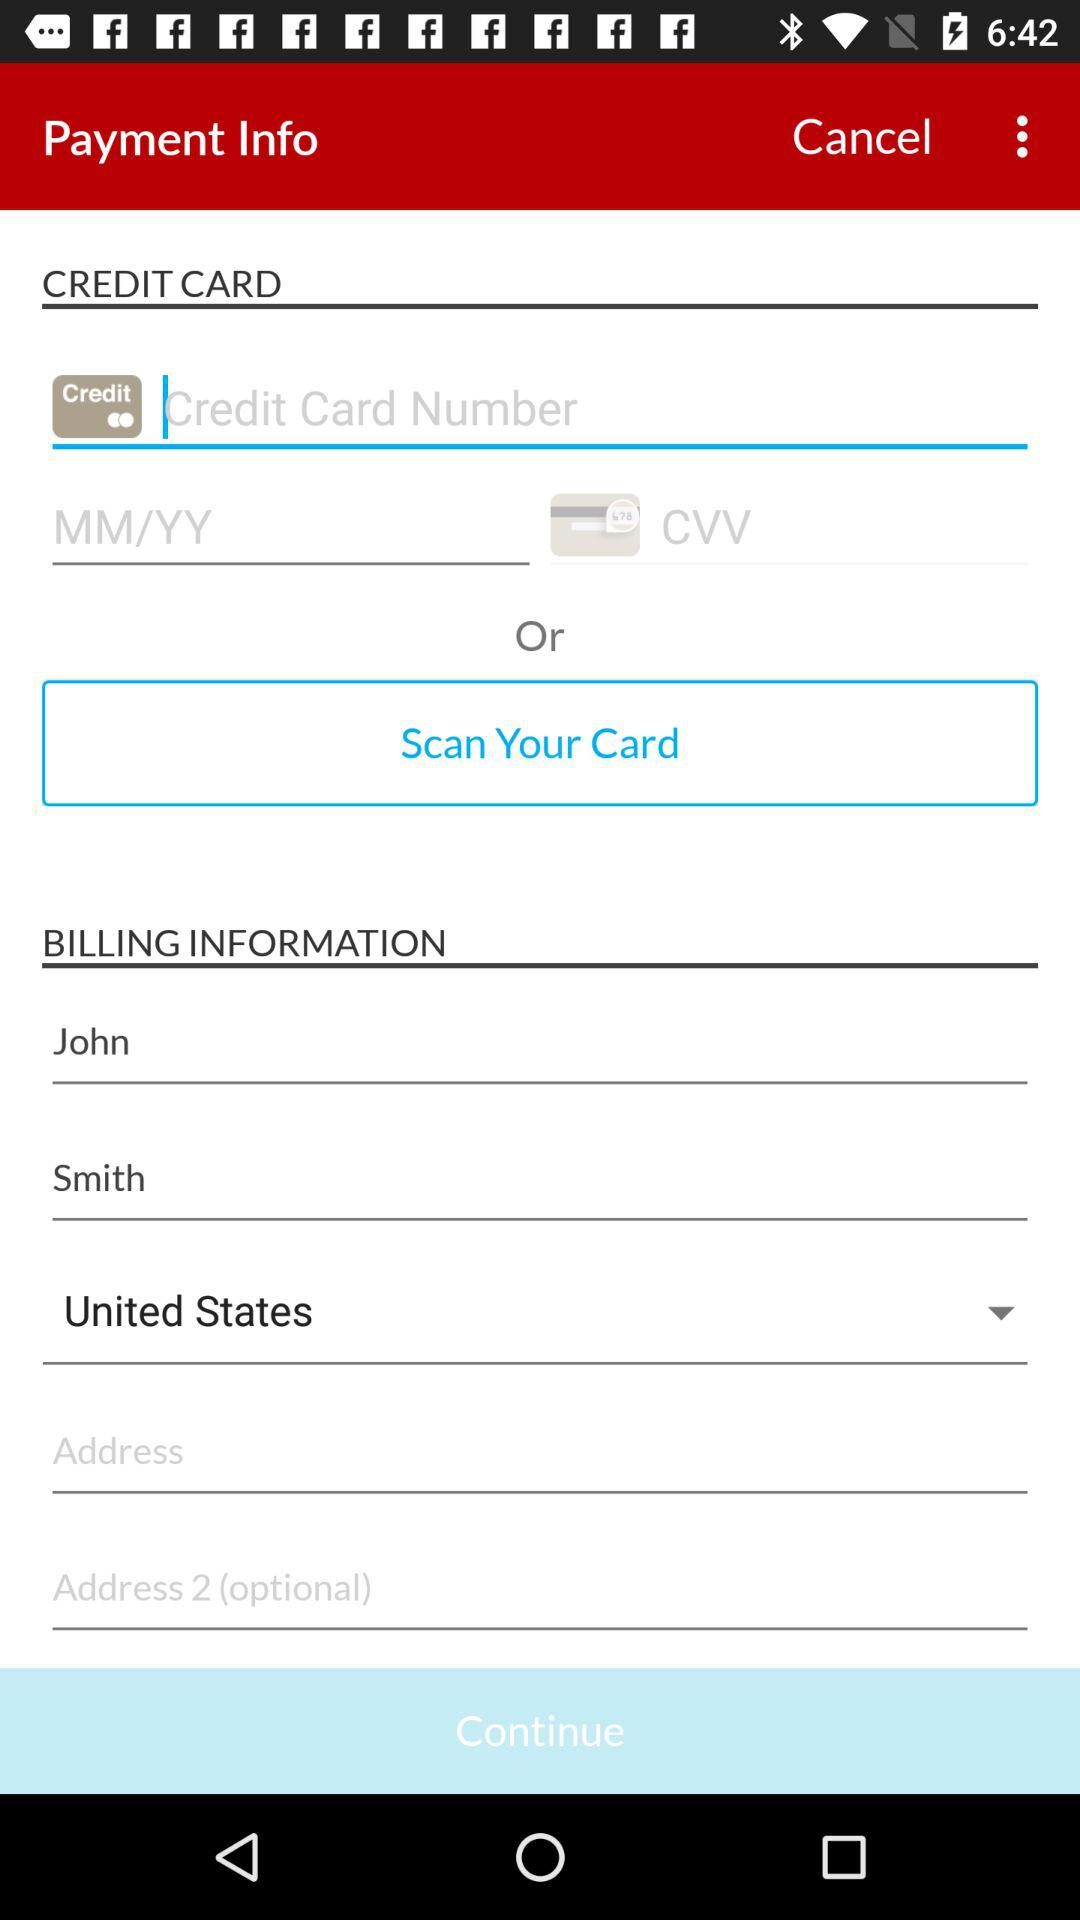What is the country name? The country name is the United States. 